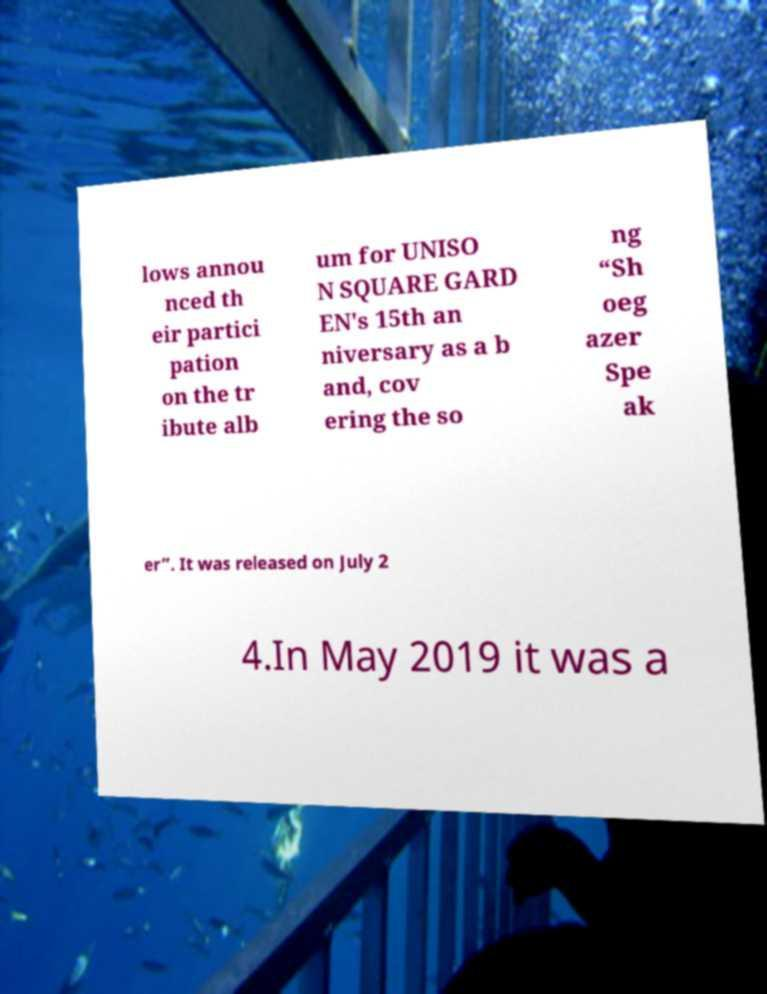Please read and relay the text visible in this image. What does it say? lows annou nced th eir partici pation on the tr ibute alb um for UNISO N SQUARE GARD EN's 15th an niversary as a b and, cov ering the so ng “Sh oeg azer Spe ak er”. It was released on July 2 4.In May 2019 it was a 